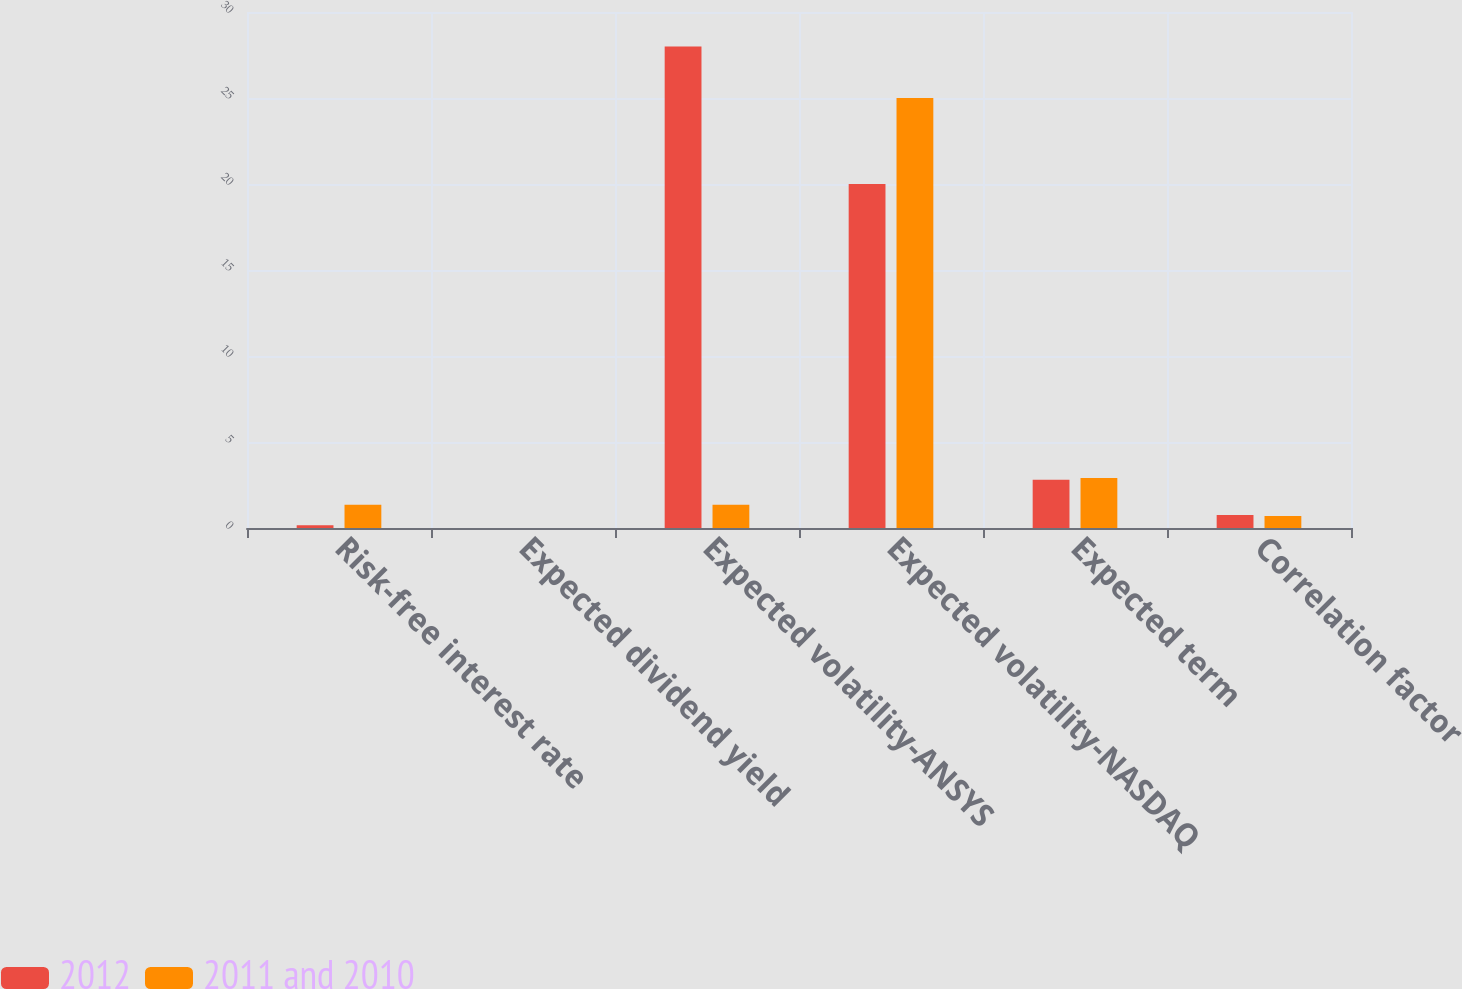<chart> <loc_0><loc_0><loc_500><loc_500><stacked_bar_chart><ecel><fcel>Risk-free interest rate<fcel>Expected dividend yield<fcel>Expected volatility-ANSYS<fcel>Expected volatility-NASDAQ<fcel>Expected term<fcel>Correlation factor<nl><fcel>2012<fcel>0.16<fcel>0<fcel>28<fcel>20<fcel>2.8<fcel>0.75<nl><fcel>2011 and 2010<fcel>1.35<fcel>0<fcel>1.35<fcel>25<fcel>2.9<fcel>0.7<nl></chart> 